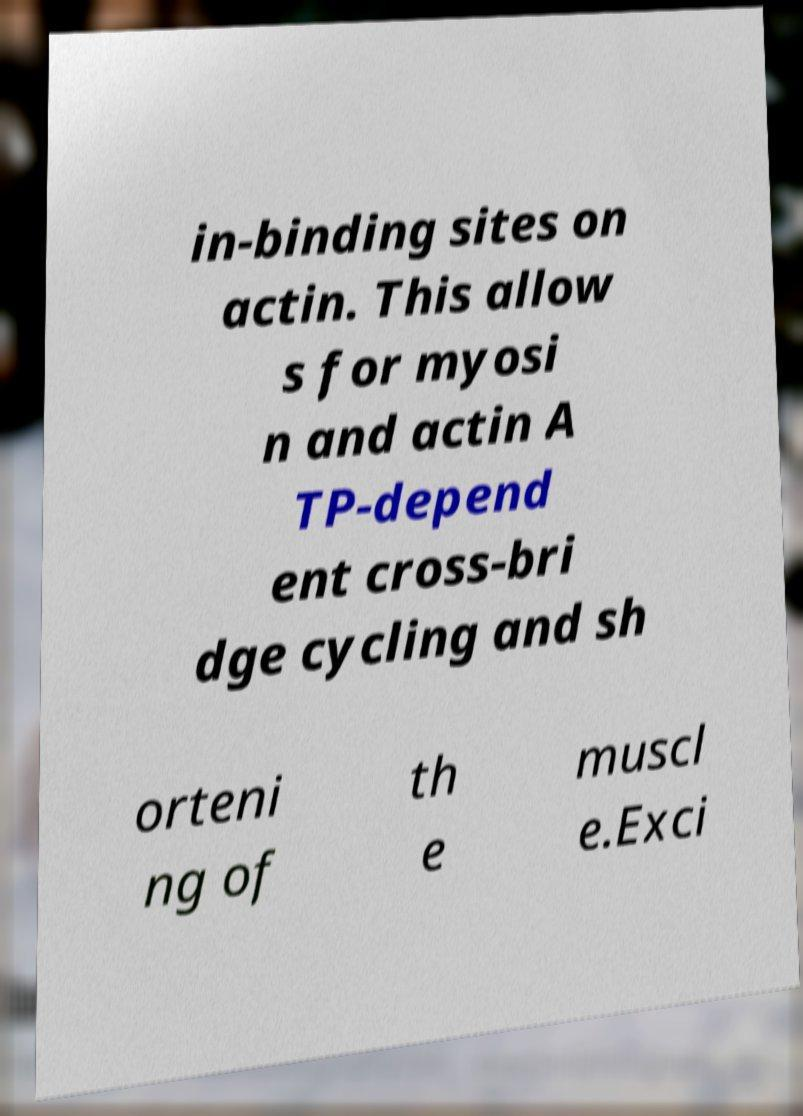Can you read and provide the text displayed in the image?This photo seems to have some interesting text. Can you extract and type it out for me? in-binding sites on actin. This allow s for myosi n and actin A TP-depend ent cross-bri dge cycling and sh orteni ng of th e muscl e.Exci 